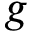<formula> <loc_0><loc_0><loc_500><loc_500>g</formula> 